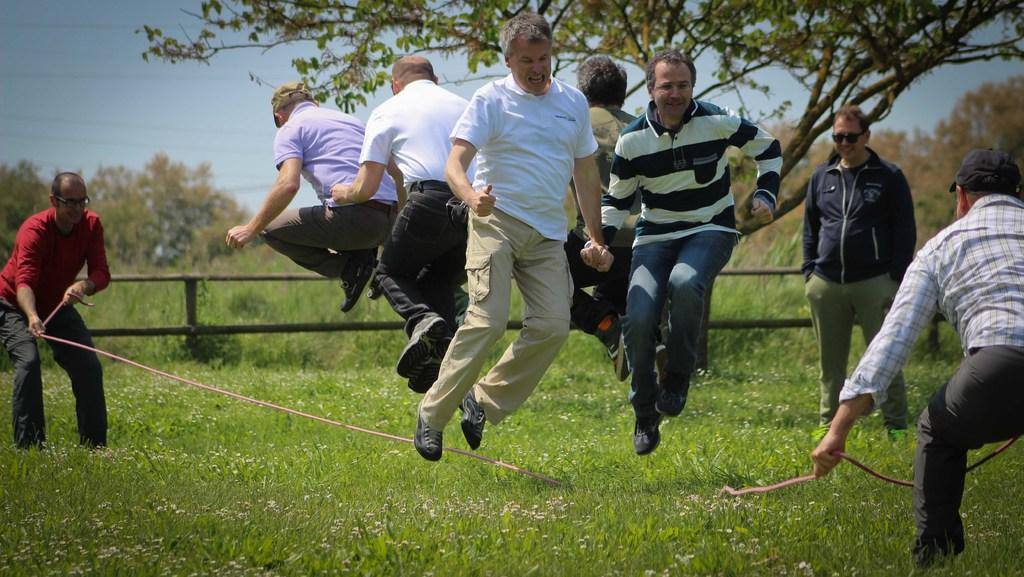Who or what can be seen in the image? There are people in the image. What type of terrain is visible in the image? There is grass in the image. What kind of barrier is present in the image? There is a fence in the image. What object can be seen in the hands of the people or lying on the ground? There is a rope in the image. What type of vegetation is present in the image? There are trees in the image. What can be seen in the distance in the image? The sky is visible in the background of the image. What type of blood is visible on the lizards in the image? There are no lizards or blood present in the image. How many trains can be seen in the image? There are no trains visible in the image. 